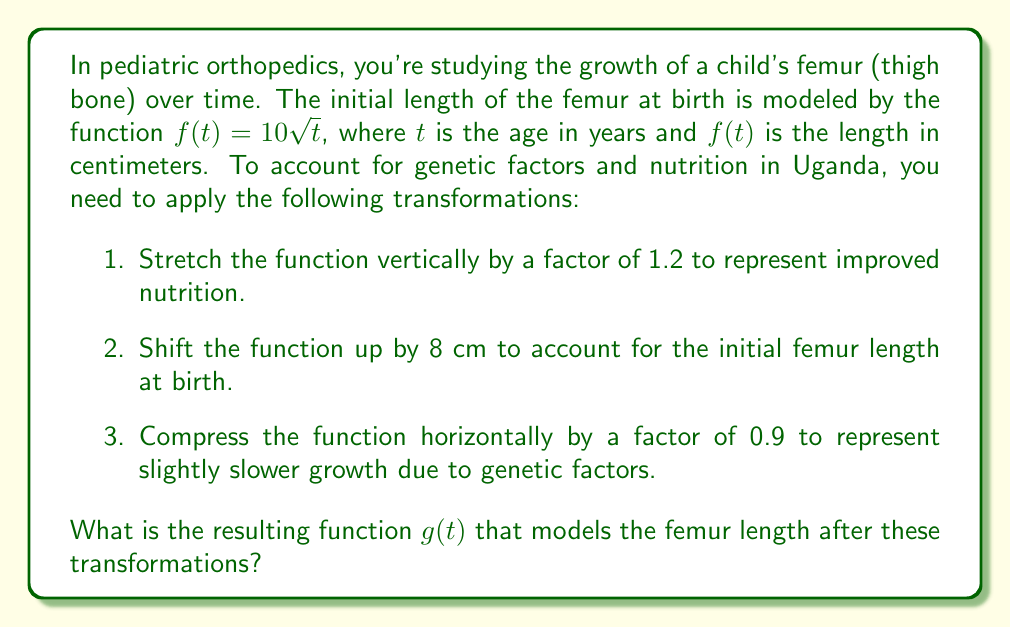Provide a solution to this math problem. Let's apply the transformations step by step:

1. Stretch vertically by a factor of 1.2:
   $f_1(t) = 1.2f(t) = 1.2(10\sqrt{t}) = 12\sqrt{t}$

2. Shift up by 8 cm:
   $f_2(t) = f_1(t) + 8 = 12\sqrt{t} + 8$

3. Compress horizontally by a factor of 0.9:
   To compress horizontally, we replace $t$ with $\frac{t}{0.9}$

   $g(t) = f_2(\frac{t}{0.9}) = 12\sqrt{\frac{t}{0.9}} + 8$

Now, let's simplify the expression under the square root:

$g(t) = 12\sqrt{\frac{t}{0.9}} + 8$

$= 12\sqrt{\frac{10t}{9}} + 8$

$= 12\sqrt{\frac{10}{9}}\sqrt{t} + 8$

$= 12 \cdot \frac{\sqrt{10}}{\sqrt{9}} \cdot \sqrt{t} + 8$

$= 12 \cdot \frac{\sqrt{10}}{3} \cdot \sqrt{t} + 8$

$= 4\sqrt{10}\sqrt{t} + 8$

Therefore, the resulting function $g(t)$ that models the femur length after these transformations is:

$g(t) = 4\sqrt{10}\sqrt{t} + 8$
Answer: $g(t) = 4\sqrt{10}\sqrt{t} + 8$ 